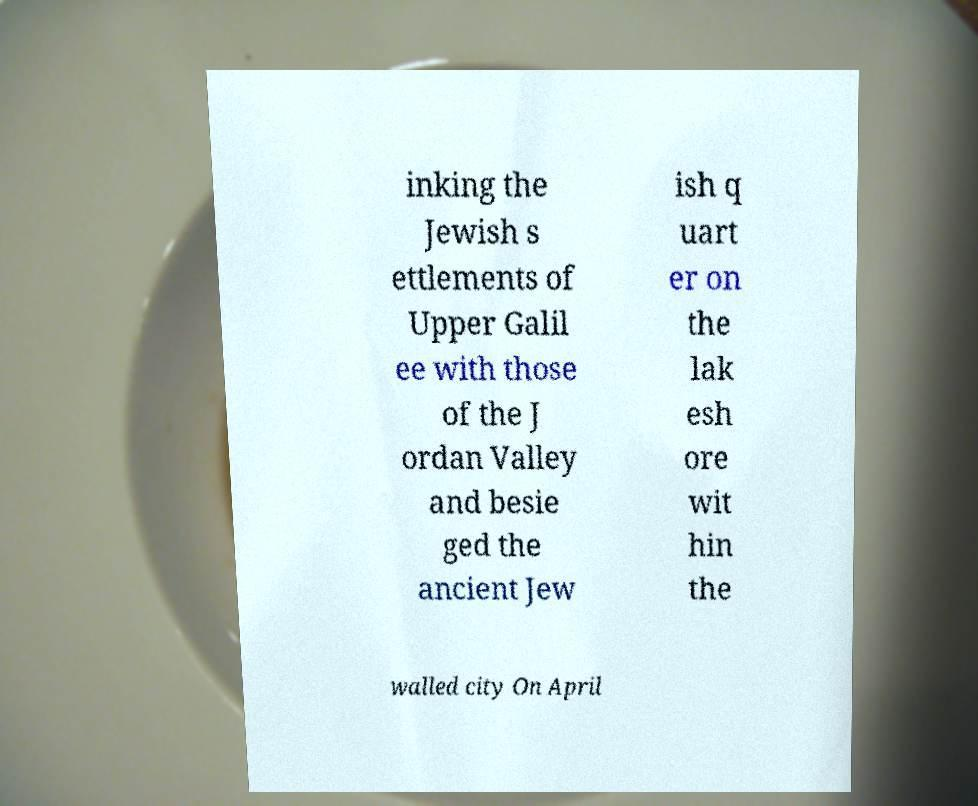For documentation purposes, I need the text within this image transcribed. Could you provide that? inking the Jewish s ettlements of Upper Galil ee with those of the J ordan Valley and besie ged the ancient Jew ish q uart er on the lak esh ore wit hin the walled city On April 